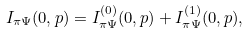<formula> <loc_0><loc_0><loc_500><loc_500>I _ { \pi \Psi } ( 0 , p ) = I _ { \pi \Psi } ^ { ( 0 ) } ( 0 , p ) + I _ { \pi \Psi } ^ { ( 1 ) } ( 0 , p ) ,</formula> 